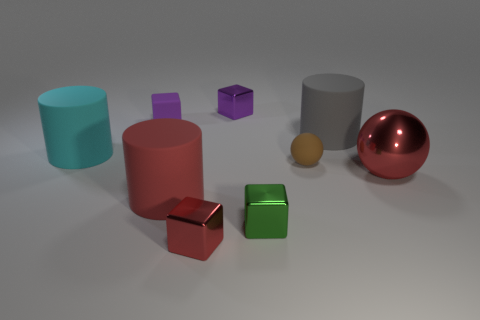Subtract all green metallic blocks. How many blocks are left? 3 Subtract all gray cylinders. How many purple cubes are left? 2 Subtract all cyan cylinders. How many cylinders are left? 2 Subtract 1 cylinders. How many cylinders are left? 2 Subtract all blocks. How many objects are left? 5 Subtract all small blue metal blocks. Subtract all red matte objects. How many objects are left? 8 Add 3 large objects. How many large objects are left? 7 Add 6 purple metallic things. How many purple metallic things exist? 7 Subtract 1 brown balls. How many objects are left? 8 Subtract all gray cubes. Subtract all brown cylinders. How many cubes are left? 4 